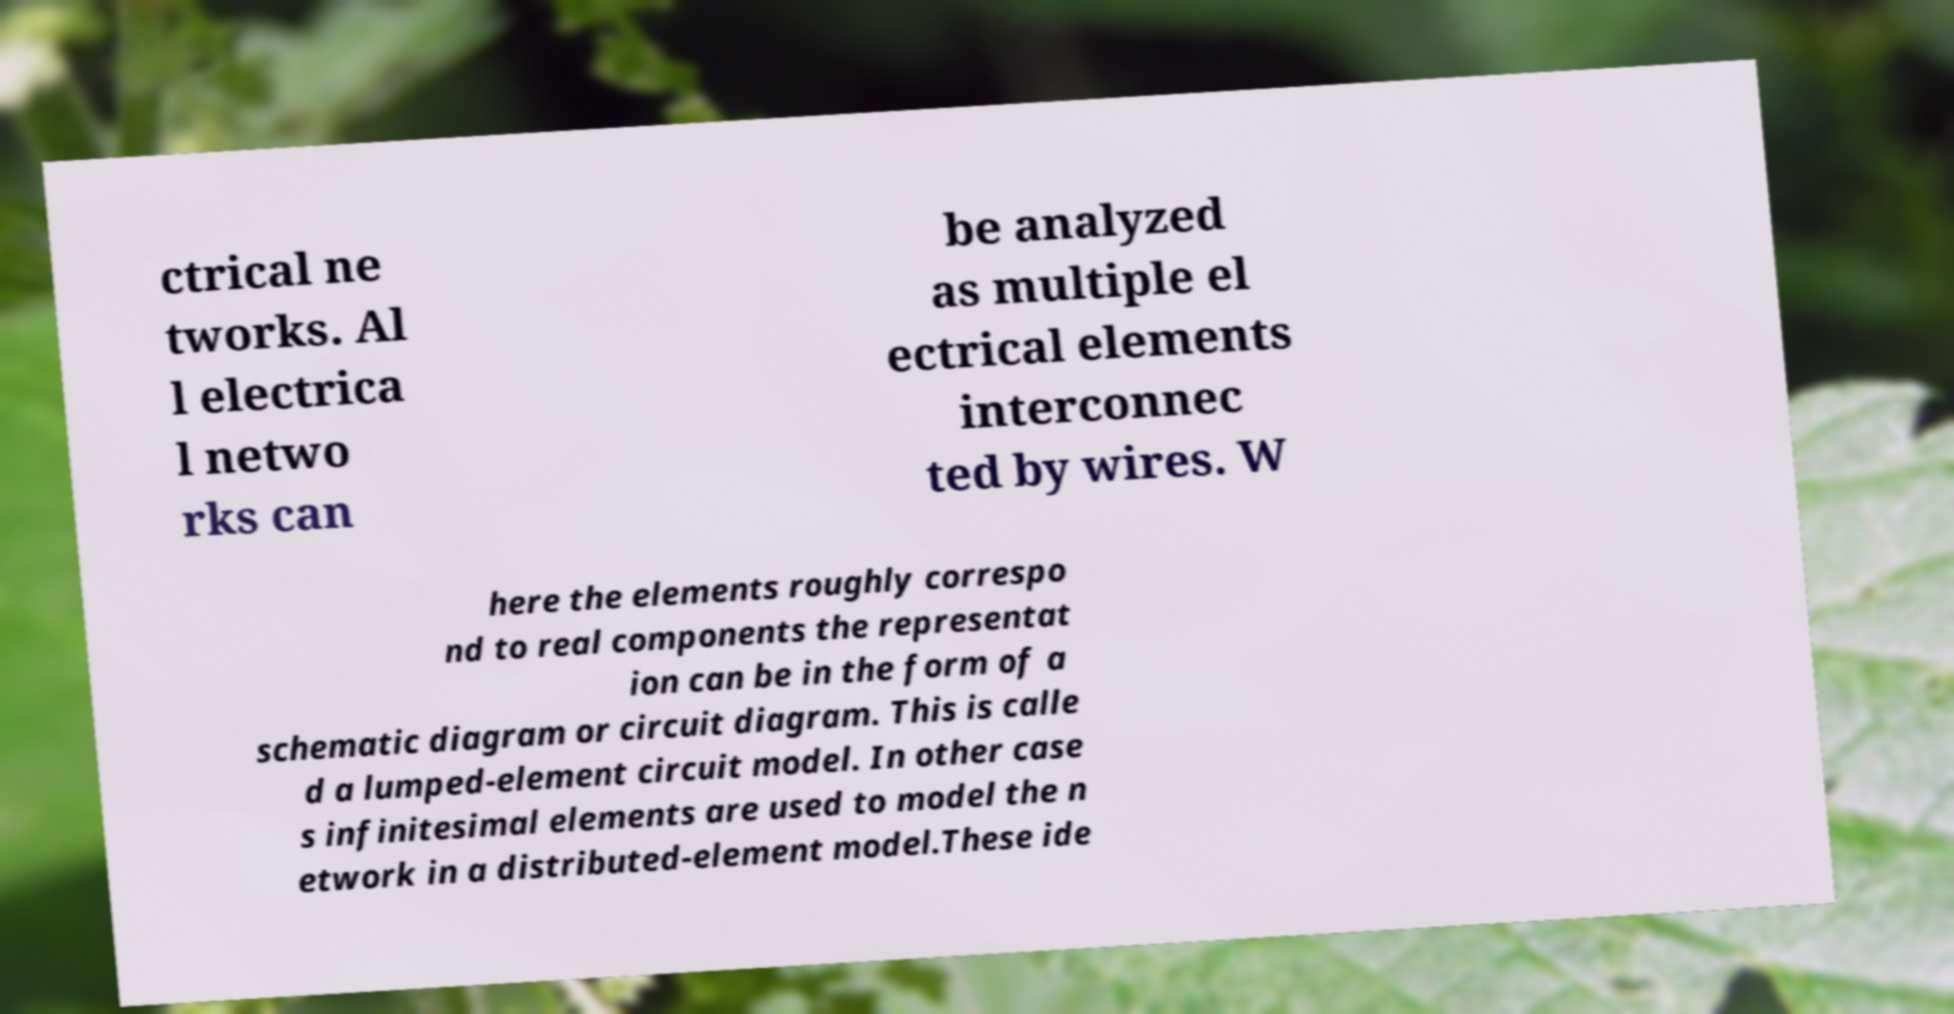For documentation purposes, I need the text within this image transcribed. Could you provide that? ctrical ne tworks. Al l electrica l netwo rks can be analyzed as multiple el ectrical elements interconnec ted by wires. W here the elements roughly correspo nd to real components the representat ion can be in the form of a schematic diagram or circuit diagram. This is calle d a lumped-element circuit model. In other case s infinitesimal elements are used to model the n etwork in a distributed-element model.These ide 